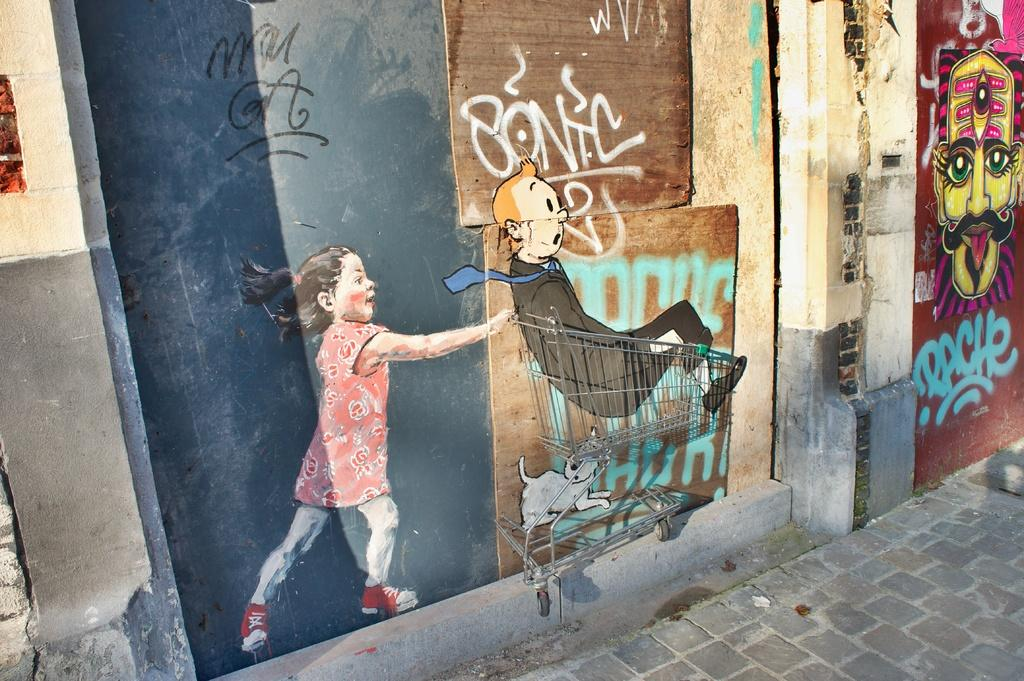What is depicted on the walls in the image? There are paintings on the walls in the image. What subjects are included in the paintings? The paintings include a girl, a cart, an animal, and a person. What type of toe can be seen in the painting with the girl? There is no toe visible in the painting with the girl, as the image only shows paintings on the walls and does not depict any toes. 